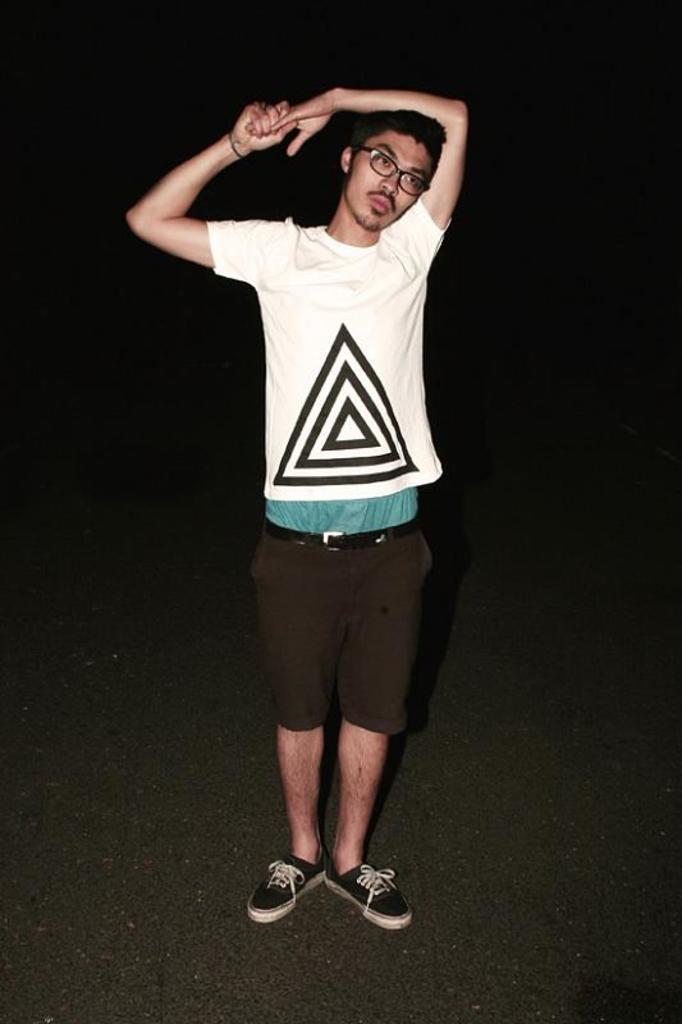Who is present in the image? There is a man in the image. Where is the man located? The man is standing on the road. What year is the example of the man's connection to the road in the image? The image does not provide information about the year, and there is no example or connection mentioned. 